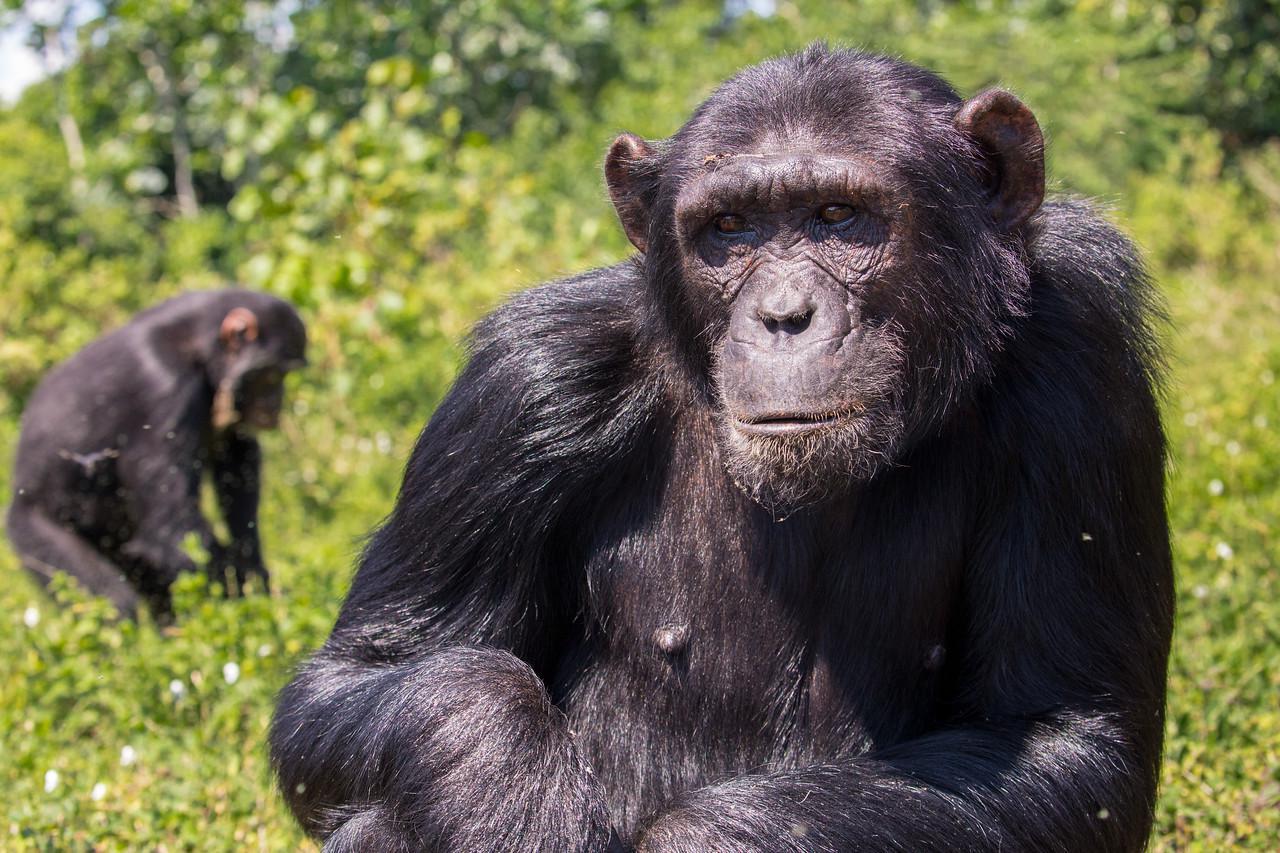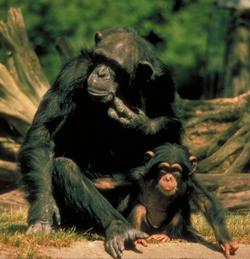The first image is the image on the left, the second image is the image on the right. Examine the images to the left and right. Is the description "At least three primates are huddled in the image on the right." accurate? Answer yes or no. No. The first image is the image on the left, the second image is the image on the right. Assess this claim about the two images: "An image shows an adult chimp in sleeping pose with its head on the left, and a smaller chimp near it.". Correct or not? Answer yes or no. No. 